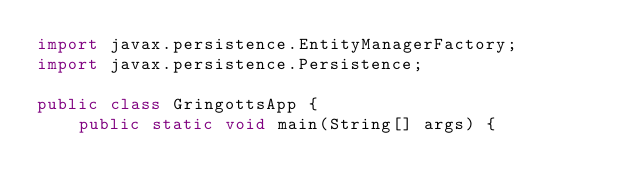Convert code to text. <code><loc_0><loc_0><loc_500><loc_500><_Java_>import javax.persistence.EntityManagerFactory;
import javax.persistence.Persistence;

public class GringottsApp {
    public static void main(String[] args) {</code> 